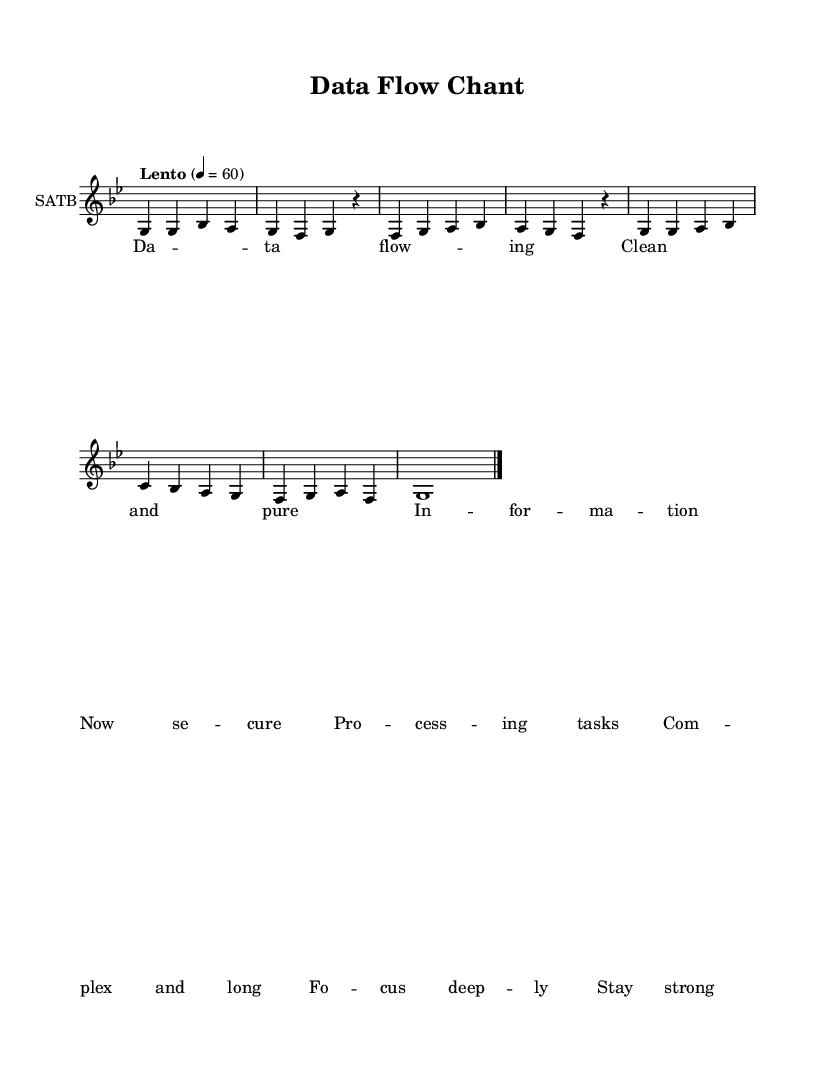What is the key signature of this music? The key signature indicated in the music is G minor, which features two flats (B flat and E flat).
Answer: G minor What is the time signature of this piece? The time signature specified in the piece is 4/4, meaning there are four beats in each measure and the quarter note gets one beat.
Answer: 4/4 What is the tempo marking for this chant? The tempo marking shows "Lento," which indicates a slow tempo, and the exact metronome marking is 60 beats per minute.
Answer: Lento How many measures are in the chant? Counting the number of groups or sections in the melody separated by bar lines, there are a total of eight measures in the chant.
Answer: Eight What is the predominant theme of the text lyrics? The lyrics centered around "Data flowing, Clean and pure," emphasize themes of clarity and focus, which align with the technical nature of data processing tasks.
Answer: Clarity What type of vocal arrangement is indicated in the score? The score indicates a SATB (Soprano, Alto, Tenor, Bass) arrangement, which designates four distinct voice parts commonly used in choral music.
Answer: SATB What mood or atmosphere does the tempo and text create? The combination of a lento tempo and contemplative lyrics fosters a meditative and focused atmosphere, conducive to processing complex tasks.
Answer: Meditative 